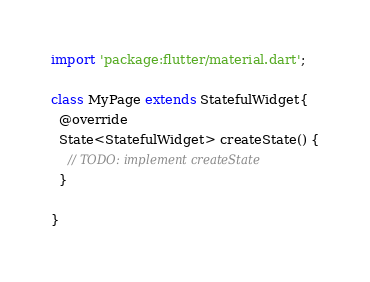Convert code to text. <code><loc_0><loc_0><loc_500><loc_500><_Dart_>import 'package:flutter/material.dart';

class MyPage extends StatefulWidget{
  @override
  State<StatefulWidget> createState() {
    // TODO: implement createState
  }

}</code> 